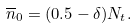Convert formula to latex. <formula><loc_0><loc_0><loc_500><loc_500>\overline { n } _ { 0 } = ( 0 . 5 - \delta ) N _ { t } .</formula> 